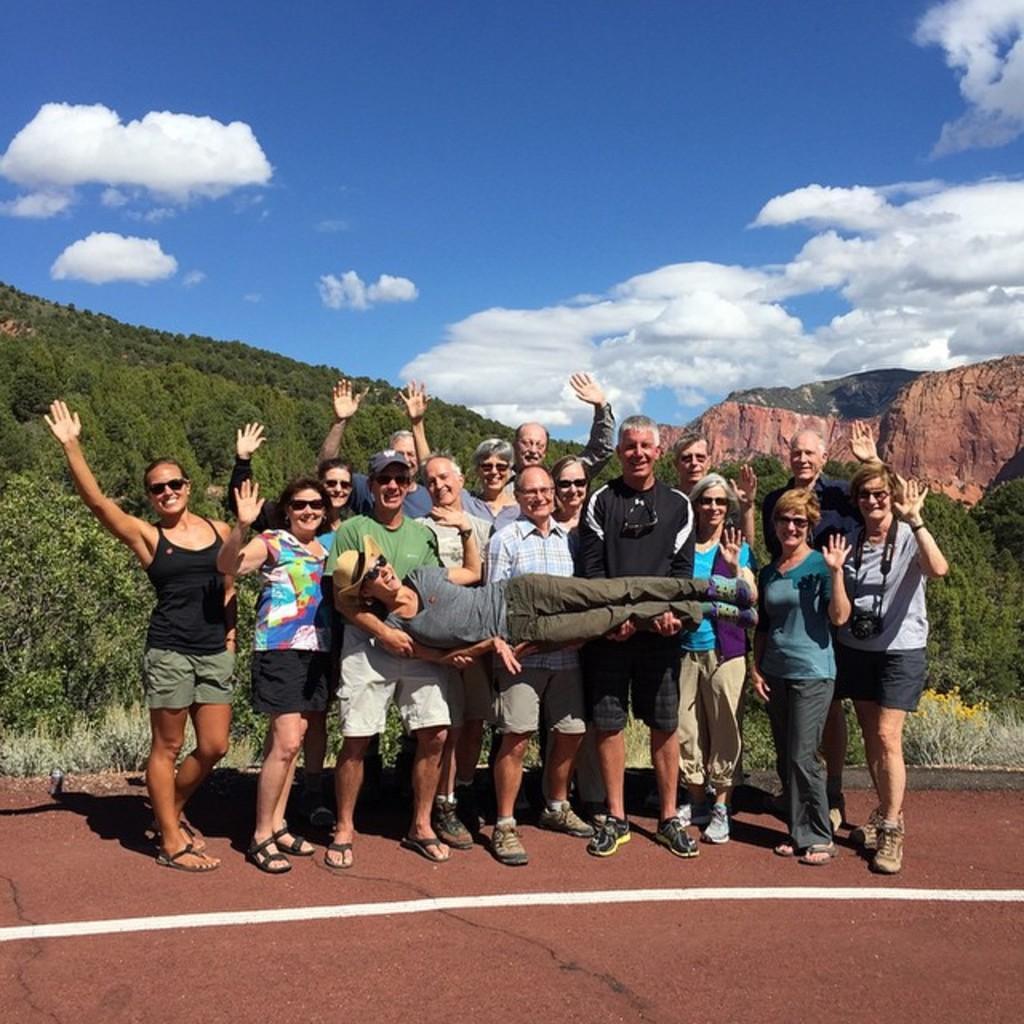Can you describe this image briefly? In this picture we can see a group of people standing on the ground and smiling were some of them are holding a person with their hands, caps, goggles, trees, mountains and in the background we can see the sky with clouds. 